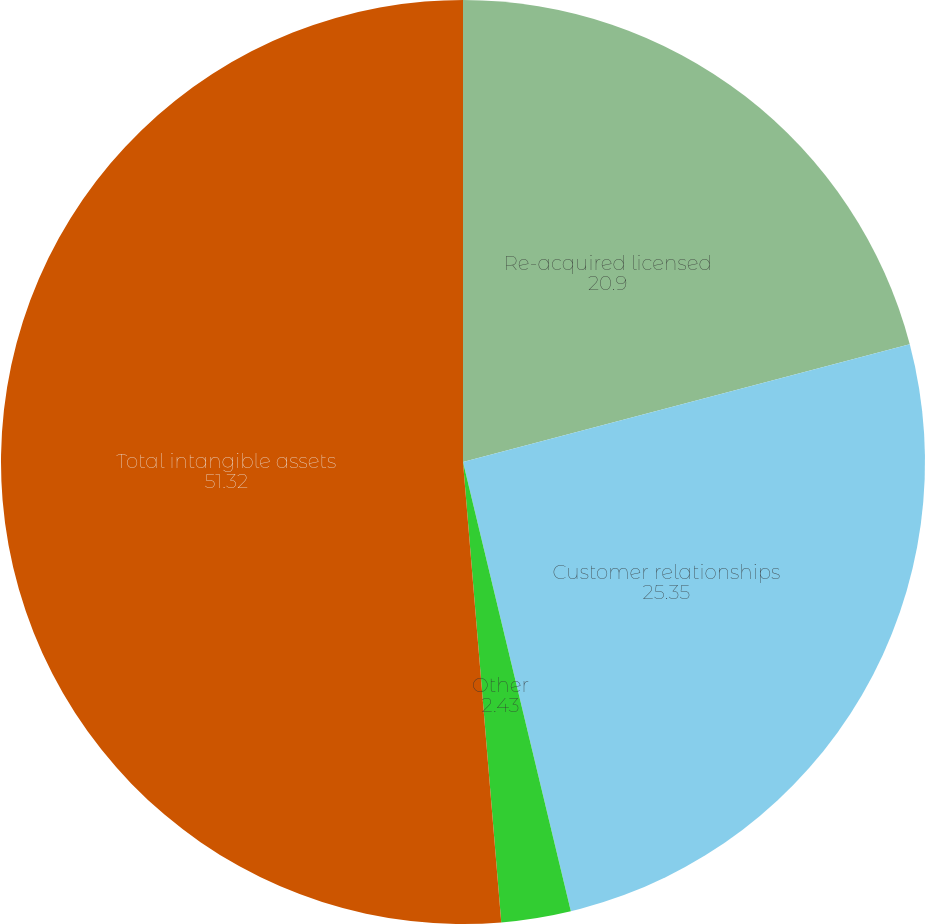Convert chart. <chart><loc_0><loc_0><loc_500><loc_500><pie_chart><fcel>Re-acquired licensed<fcel>Customer relationships<fcel>Other<fcel>Total intangible assets<nl><fcel>20.9%<fcel>25.35%<fcel>2.43%<fcel>51.32%<nl></chart> 